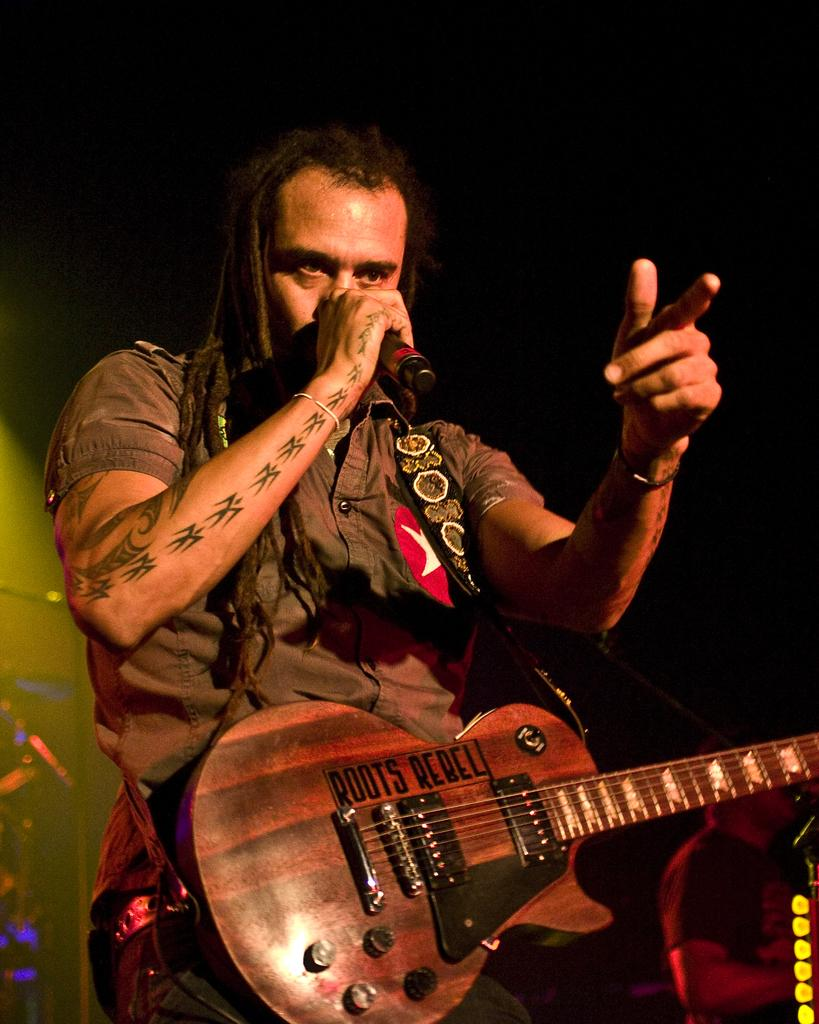What is the person in the image doing? The person is carrying a guitar and singing. What object is present in the image that is typically used for amplifying sound? There is a microphone in the image. How many people are in the crowd watching the person's performance in the image? There is no crowd present in the image; it only shows a person carrying a guitar and singing with a microphone nearby. 